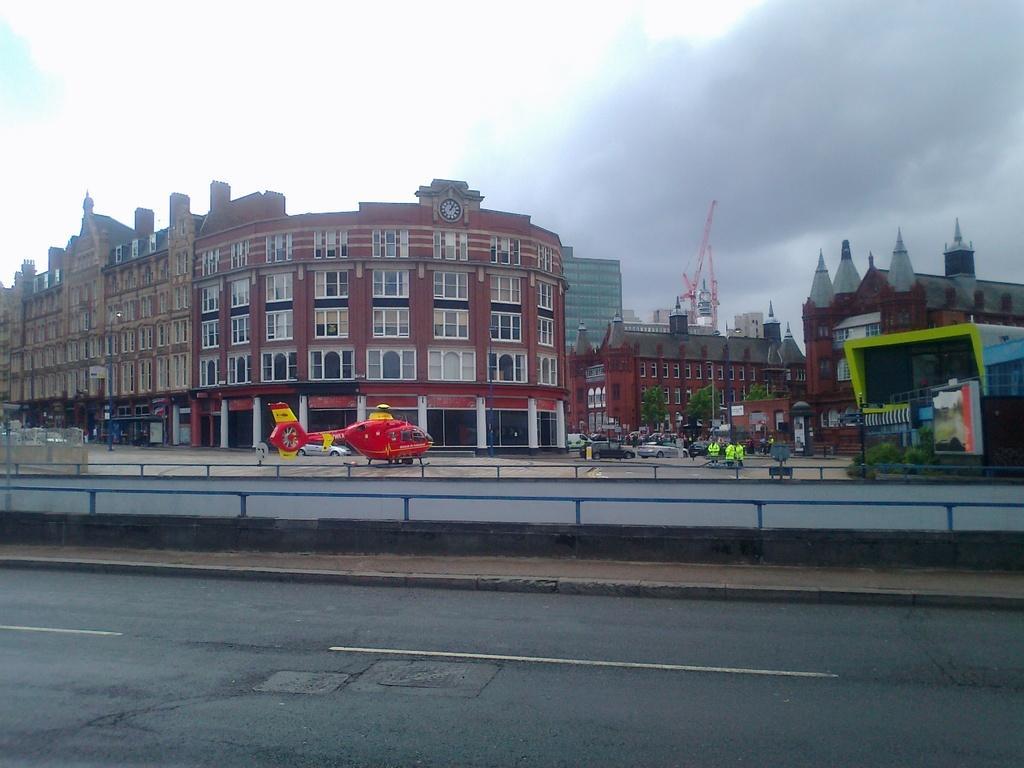In one or two sentences, can you explain what this image depicts? In the center of the image there is a depiction of helicopter. In the background of the image there are buildings. At the bottom of the image there is road. At the top of the image there is sky and clouds. 